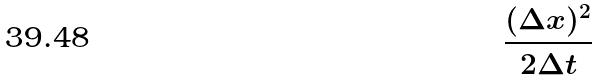<formula> <loc_0><loc_0><loc_500><loc_500>\frac { ( \Delta x ) ^ { 2 } } { 2 \Delta t }</formula> 